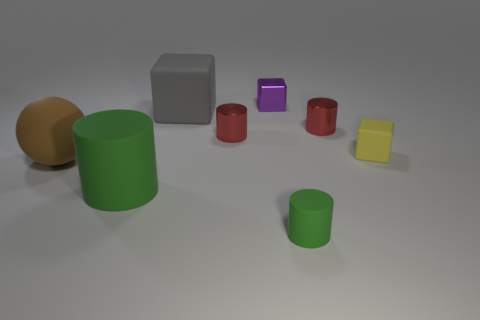Add 2 tiny cylinders. How many objects exist? 10 Subtract all spheres. How many objects are left? 7 Subtract all small metallic cylinders. Subtract all yellow rubber things. How many objects are left? 5 Add 1 small red metal cylinders. How many small red metal cylinders are left? 3 Add 5 metal cylinders. How many metal cylinders exist? 7 Subtract 0 green blocks. How many objects are left? 8 